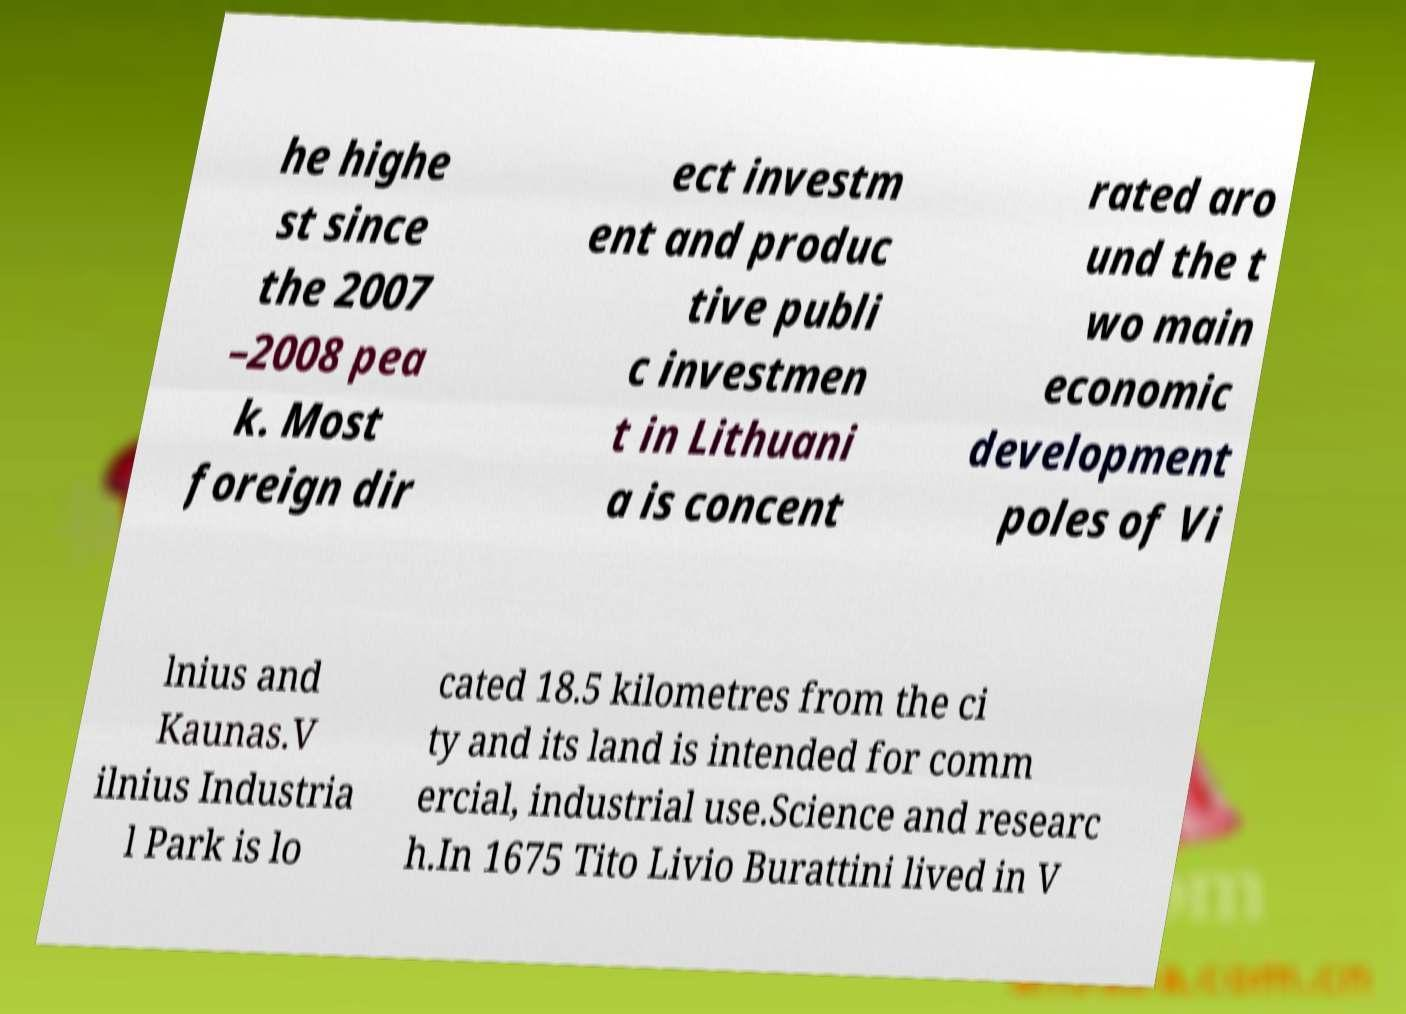Can you read and provide the text displayed in the image?This photo seems to have some interesting text. Can you extract and type it out for me? he highe st since the 2007 –2008 pea k. Most foreign dir ect investm ent and produc tive publi c investmen t in Lithuani a is concent rated aro und the t wo main economic development poles of Vi lnius and Kaunas.V ilnius Industria l Park is lo cated 18.5 kilometres from the ci ty and its land is intended for comm ercial, industrial use.Science and researc h.In 1675 Tito Livio Burattini lived in V 